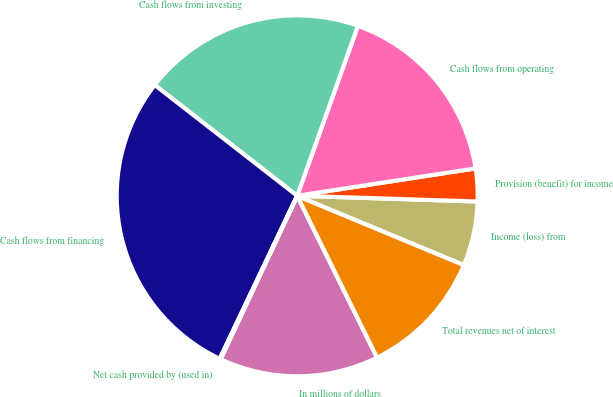Convert chart. <chart><loc_0><loc_0><loc_500><loc_500><pie_chart><fcel>In millions of dollars<fcel>Total revenues net of interest<fcel>Income (loss) from<fcel>Provision (benefit) for income<fcel>Cash flows from operating<fcel>Cash flows from investing<fcel>Cash flows from financing<fcel>Net cash provided by (used in)<nl><fcel>14.27%<fcel>11.44%<fcel>5.76%<fcel>2.93%<fcel>17.11%<fcel>19.94%<fcel>28.45%<fcel>0.09%<nl></chart> 